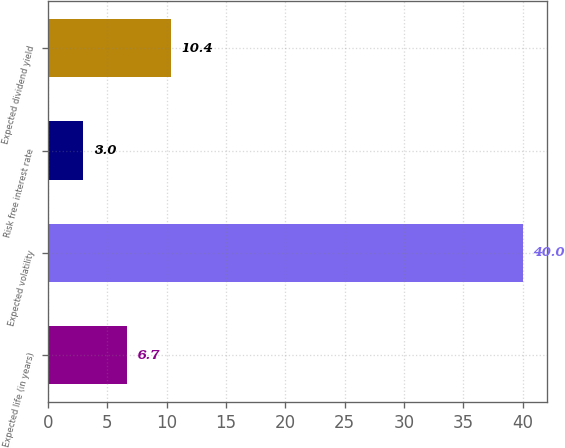Convert chart. <chart><loc_0><loc_0><loc_500><loc_500><bar_chart><fcel>Expected life (in years)<fcel>Expected volatility<fcel>Risk free interest rate<fcel>Expected dividend yield<nl><fcel>6.7<fcel>40<fcel>3<fcel>10.4<nl></chart> 